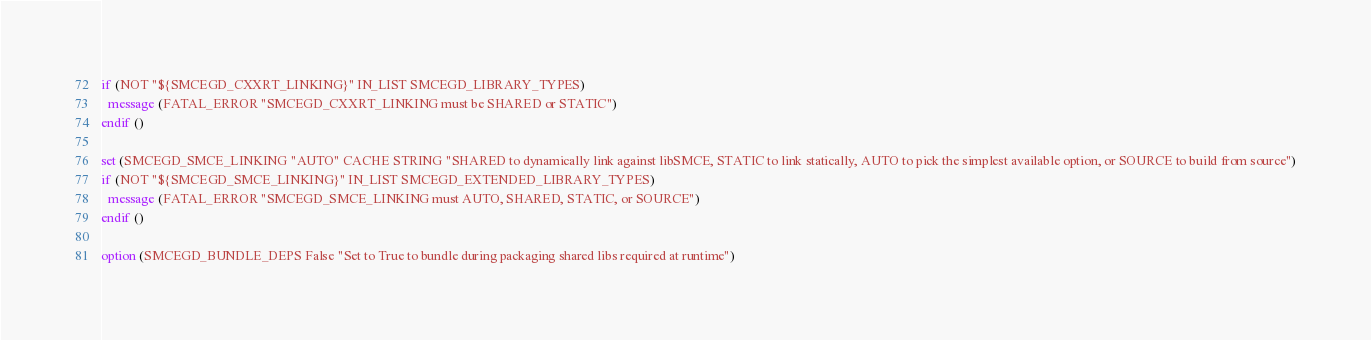<code> <loc_0><loc_0><loc_500><loc_500><_CMake_>if (NOT "${SMCEGD_CXXRT_LINKING}" IN_LIST SMCEGD_LIBRARY_TYPES)
  message (FATAL_ERROR "SMCEGD_CXXRT_LINKING must be SHARED or STATIC")
endif ()

set (SMCEGD_SMCE_LINKING "AUTO" CACHE STRING "SHARED to dynamically link against libSMCE, STATIC to link statically, AUTO to pick the simplest available option, or SOURCE to build from source")
if (NOT "${SMCEGD_SMCE_LINKING}" IN_LIST SMCEGD_EXTENDED_LIBRARY_TYPES)
  message (FATAL_ERROR "SMCEGD_SMCE_LINKING must AUTO, SHARED, STATIC, or SOURCE")
endif ()

option (SMCEGD_BUNDLE_DEPS False "Set to True to bundle during packaging shared libs required at runtime")
</code> 